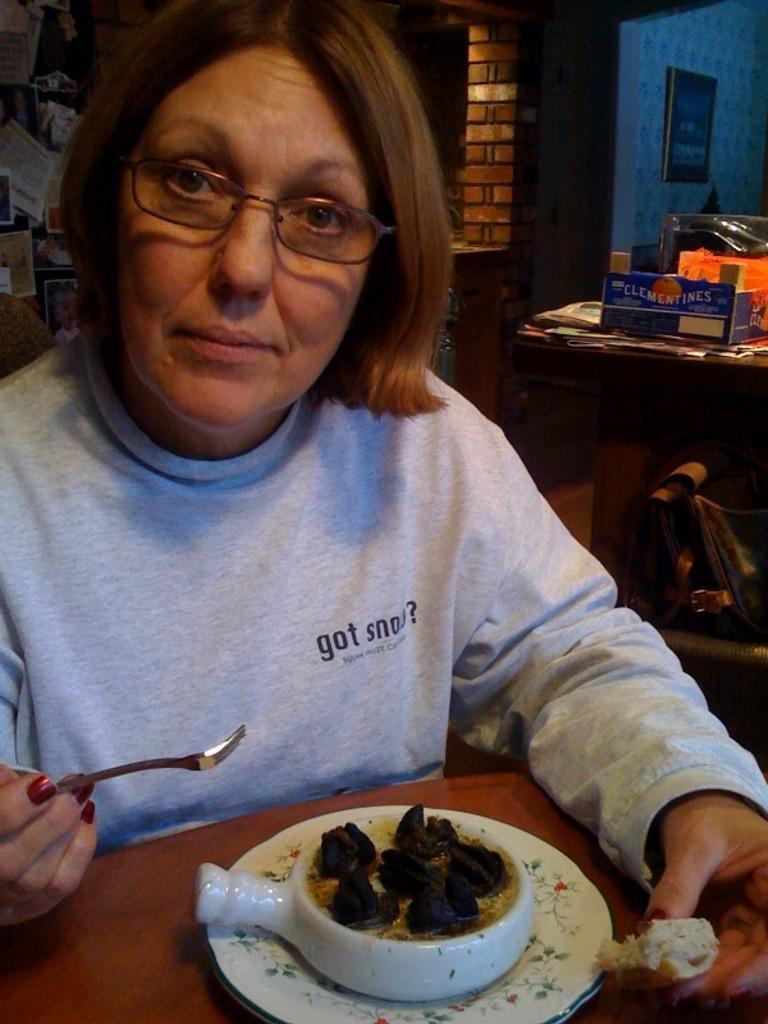Could you give a brief overview of what you see in this image? In this image I can see a person sitting wearing gray color shirt, in front I can see food in the bowl and the bowl is in white color and I can also see the person holding a spoon. Background I can see a cardboard box on the table and a frame attached to the wall. 